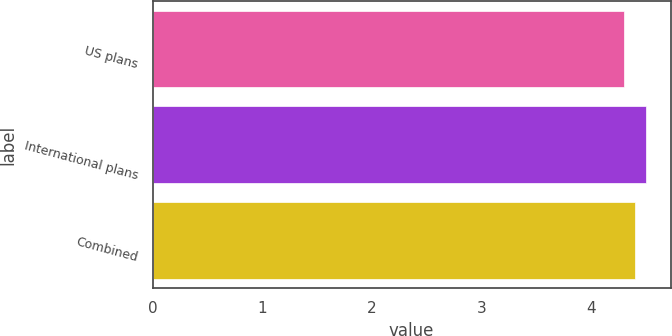Convert chart. <chart><loc_0><loc_0><loc_500><loc_500><bar_chart><fcel>US plans<fcel>International plans<fcel>Combined<nl><fcel>4.3<fcel>4.5<fcel>4.4<nl></chart> 